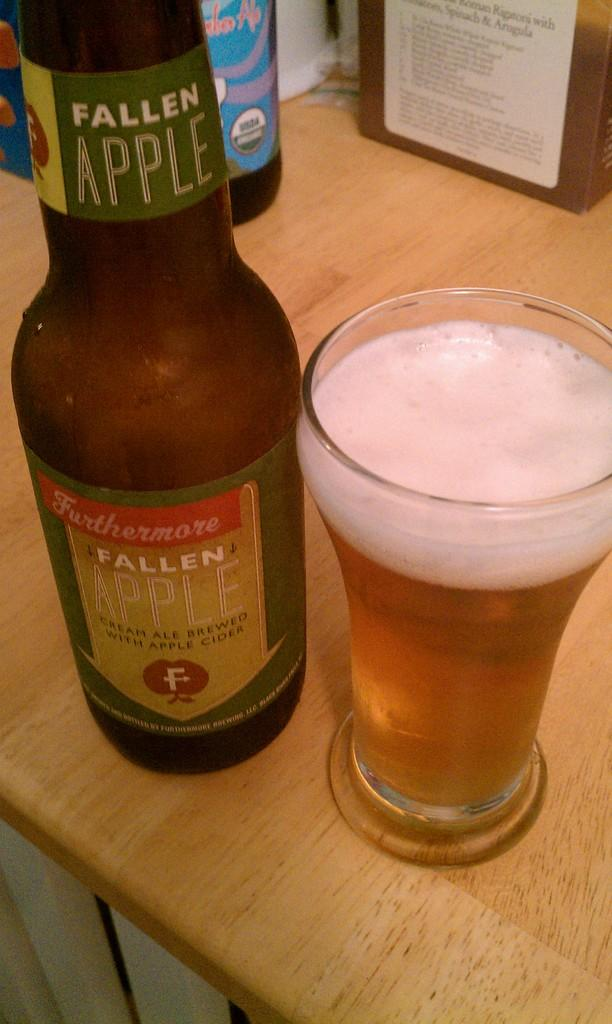Provide a one-sentence caption for the provided image. Fallen Apple cream ale has been poured into the glass on the right. 